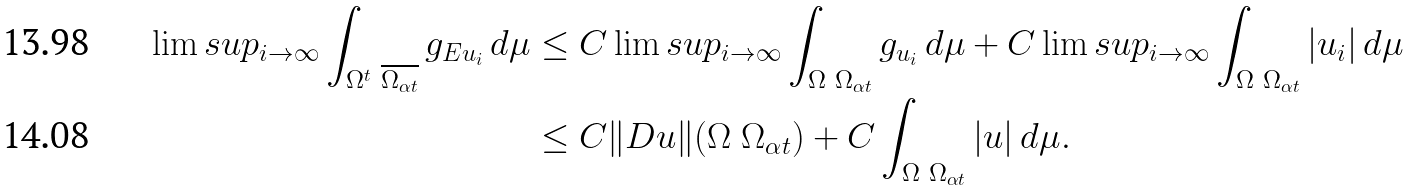<formula> <loc_0><loc_0><loc_500><loc_500>\lim s u p _ { i \to \infty } \int _ { \Omega ^ { t } \ \overline { \Omega _ { \alpha t } } } g _ { E u _ { i } } \, d \mu & \leq C \lim s u p _ { i \to \infty } \int _ { \Omega \ \Omega _ { \alpha t } } g _ { u _ { i } } \, d \mu + C \lim s u p _ { i \to \infty } \int _ { \Omega \ \Omega _ { \alpha t } } | u _ { i } | \, d \mu \\ & \leq C \| D u \| ( \Omega \ \Omega _ { \alpha t } ) + C \int _ { \Omega \ \Omega _ { \alpha t } } | u | \, d \mu .</formula> 